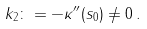Convert formula to latex. <formula><loc_0><loc_0><loc_500><loc_500>k _ { 2 } \colon = - \kappa ^ { \prime \prime } ( s _ { 0 } ) \neq 0 \, .</formula> 